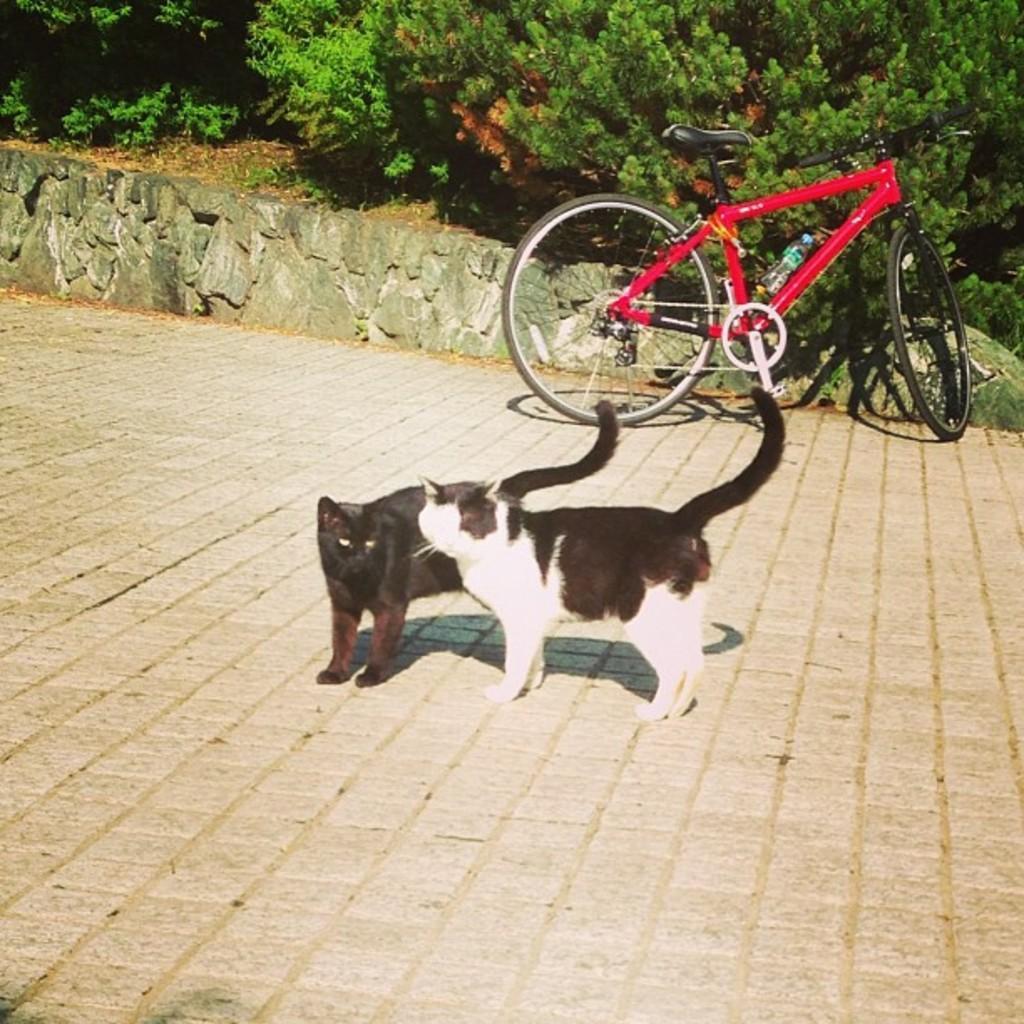In one or two sentences, can you explain what this image depicts? In the center of the picture there are two cats. In the background there are trees, soil, wall and a bicycle. 